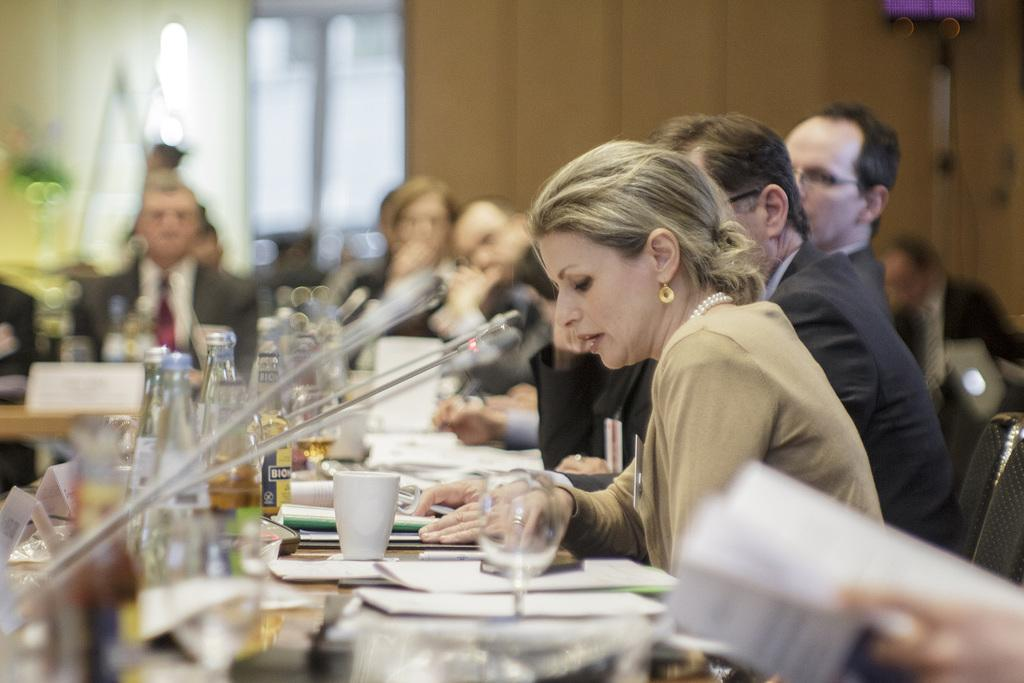How many people are in the image? There is a group of people in the image. What are the people doing in the image? The people are sitting on chairs. Where are the chairs located in relation to the table? The chairs are in front of a table. What type of containers can be seen on the table? There are glass bottles and cups on the table. What other objects are present on the table? There are other objects on the table. Who is the queen sitting among the people in the image? There is no queen present in the image; it features a group of people sitting on chairs in front of a table. 